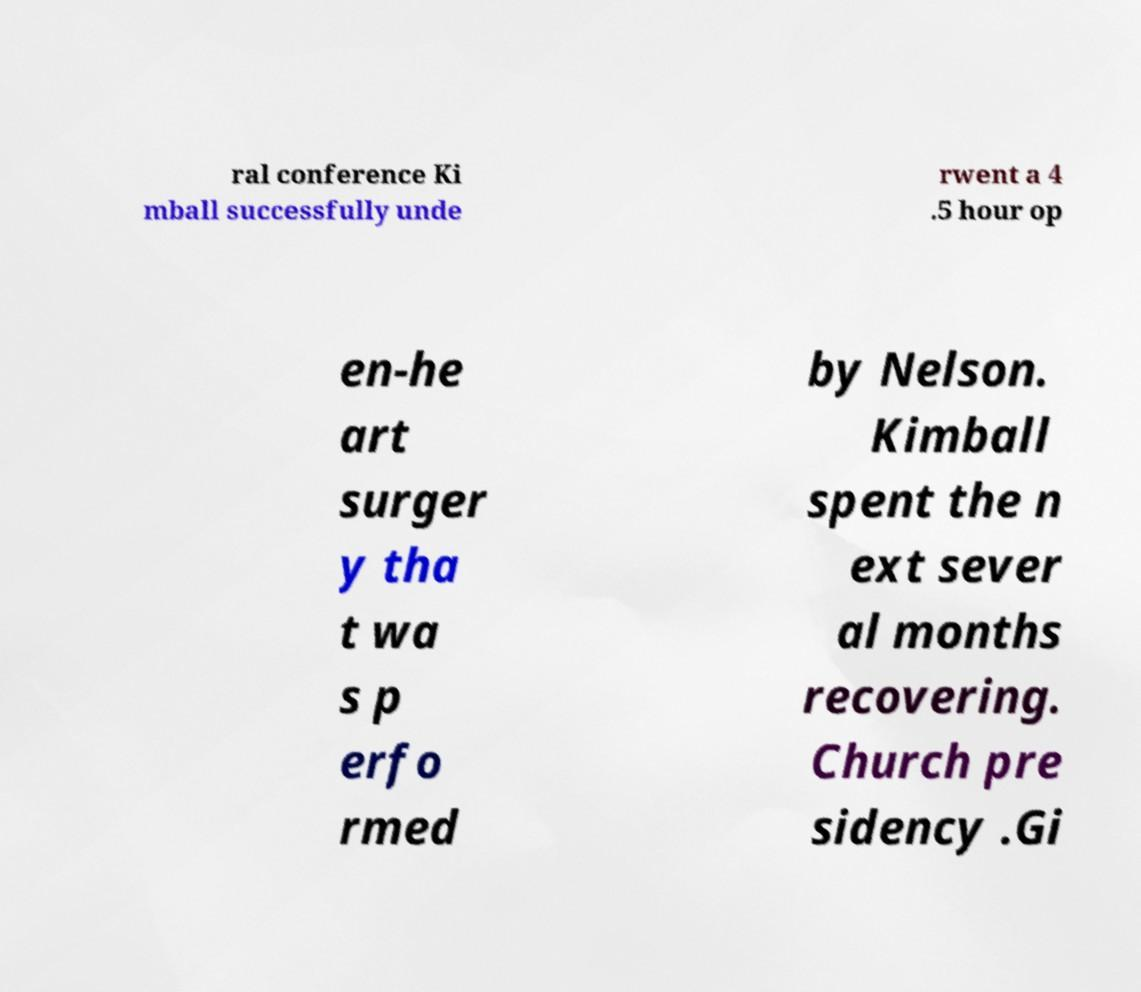Can you read and provide the text displayed in the image?This photo seems to have some interesting text. Can you extract and type it out for me? ral conference Ki mball successfully unde rwent a 4 .5 hour op en-he art surger y tha t wa s p erfo rmed by Nelson. Kimball spent the n ext sever al months recovering. Church pre sidency .Gi 